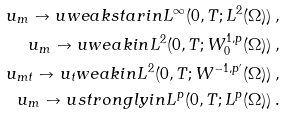<formula> <loc_0><loc_0><loc_500><loc_500>u _ { m } \to u w e a k s t a r i n L ^ { \infty } ( 0 , T ; L ^ { 2 } ( \Omega ) ) \, , \\ u _ { m } \to u w e a k i n L ^ { 2 } ( 0 , T ; W ^ { 1 , p } _ { 0 } ( \Omega ) ) \, , \\ u _ { m t } \to u _ { t } w e a k i n L ^ { 2 } ( 0 , T ; W ^ { - 1 , p ^ { \prime } } ( \Omega ) ) \, , \\ u _ { m } \to u s t r o n g l y i n L ^ { p } ( 0 , T ; L ^ { p } ( \Omega ) ) \, .</formula> 